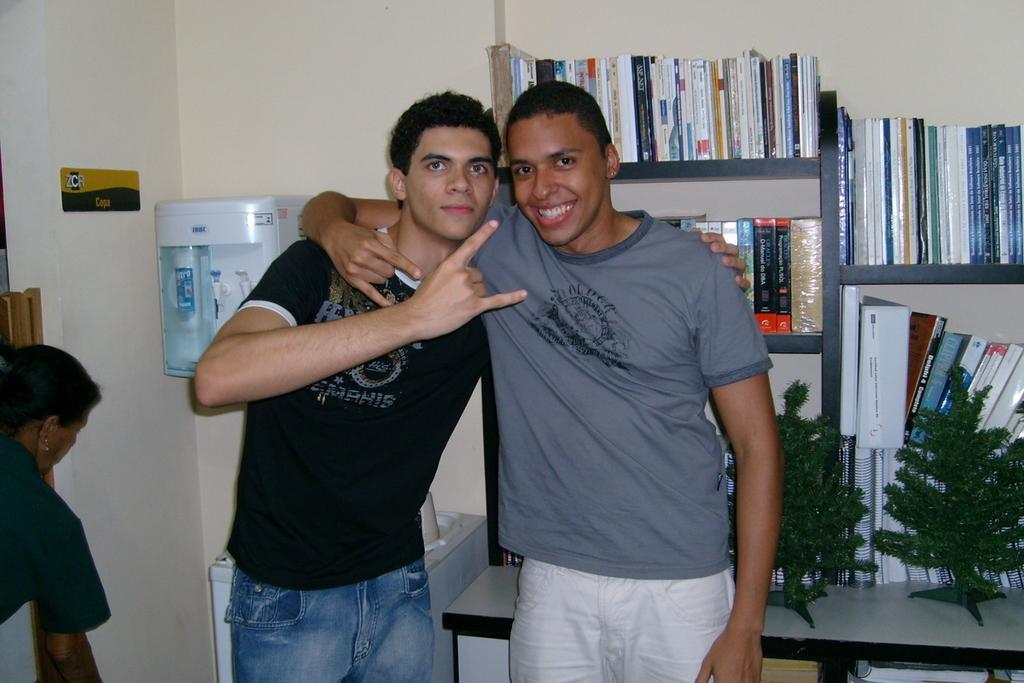Please provide a concise description of this image. In the picture we can see a two men are standing on the floor in the house, behind them, we can see a table and some artificial plant on it and into the wall we can see some rocks with a book and besides we can see a water purifier to the wall. 